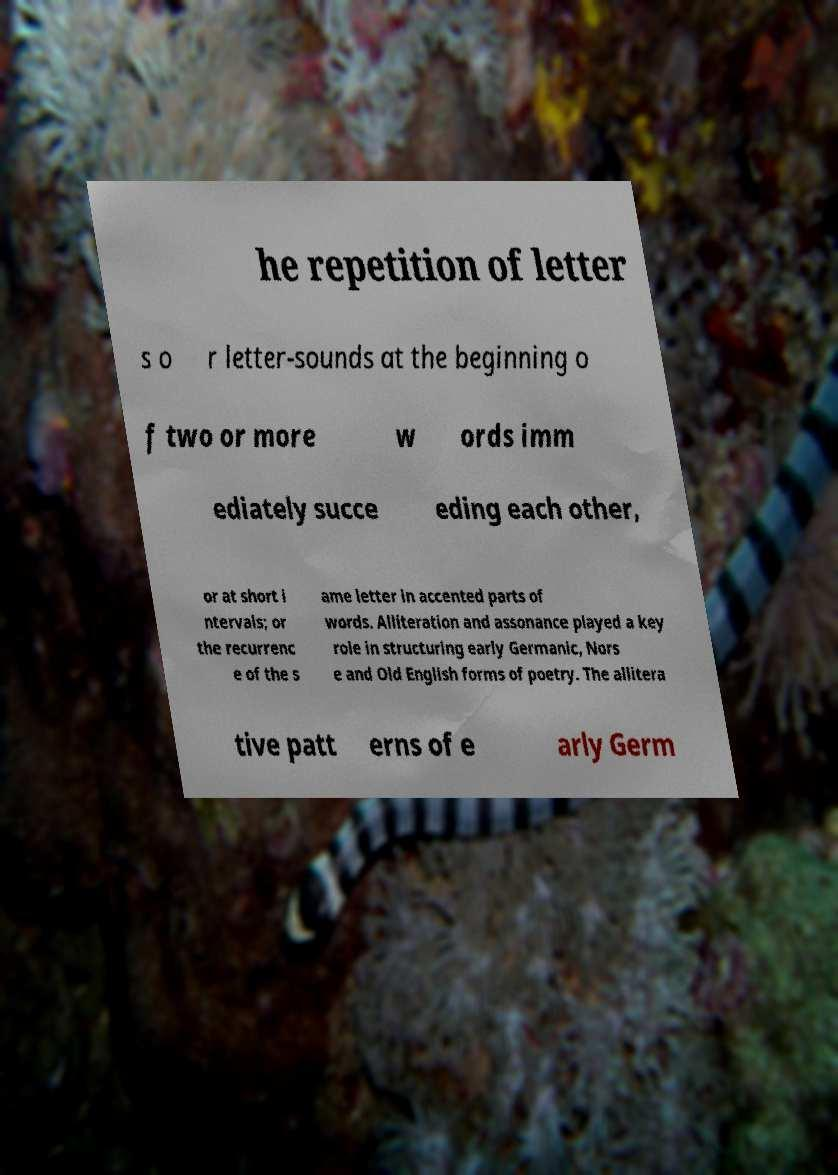There's text embedded in this image that I need extracted. Can you transcribe it verbatim? he repetition of letter s o r letter-sounds at the beginning o f two or more w ords imm ediately succe eding each other, or at short i ntervals; or the recurrenc e of the s ame letter in accented parts of words. Alliteration and assonance played a key role in structuring early Germanic, Nors e and Old English forms of poetry. The allitera tive patt erns of e arly Germ 